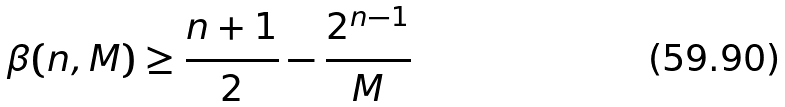Convert formula to latex. <formula><loc_0><loc_0><loc_500><loc_500>\beta ( n , M ) \geq \frac { n + 1 } { 2 } - \frac { 2 ^ { n - 1 } } { M }</formula> 